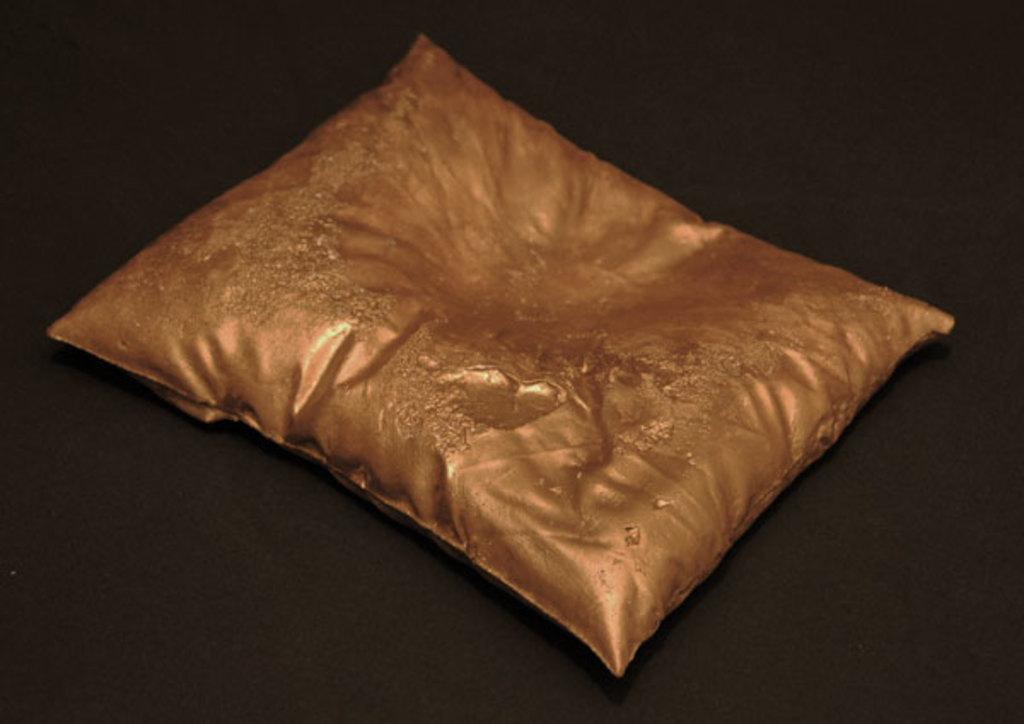What color is the pillow in the image? The pillow in the image is golden in color. What is the pillow placed on in the image? The pillow is on a black color surface. How many family members can be seen interacting with the pot on the road in the image? There is no family, pot, or road present in the image; it only features a golden color pillow on a black color surface. 